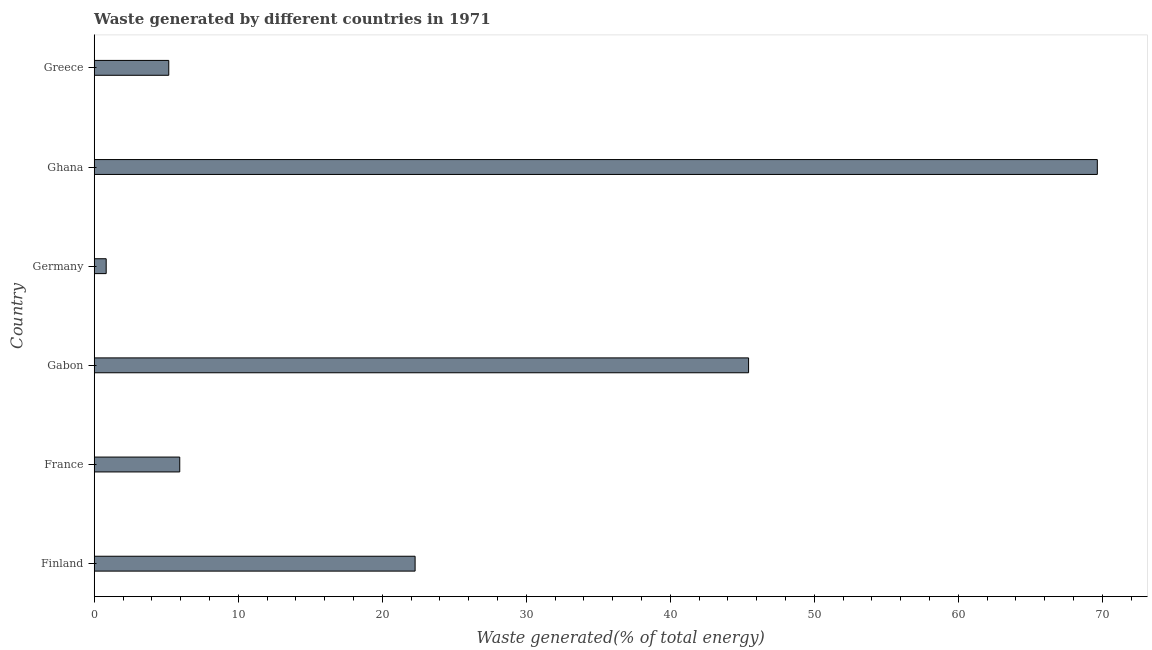Does the graph contain any zero values?
Offer a very short reply. No. Does the graph contain grids?
Ensure brevity in your answer.  No. What is the title of the graph?
Your answer should be very brief. Waste generated by different countries in 1971. What is the label or title of the X-axis?
Keep it short and to the point. Waste generated(% of total energy). What is the label or title of the Y-axis?
Keep it short and to the point. Country. What is the amount of waste generated in France?
Keep it short and to the point. 5.94. Across all countries, what is the maximum amount of waste generated?
Offer a terse response. 69.65. Across all countries, what is the minimum amount of waste generated?
Your response must be concise. 0.83. In which country was the amount of waste generated maximum?
Provide a succinct answer. Ghana. In which country was the amount of waste generated minimum?
Ensure brevity in your answer.  Germany. What is the sum of the amount of waste generated?
Your answer should be very brief. 149.32. What is the difference between the amount of waste generated in Germany and Greece?
Offer a very short reply. -4.34. What is the average amount of waste generated per country?
Make the answer very short. 24.89. What is the median amount of waste generated?
Keep it short and to the point. 14.11. In how many countries, is the amount of waste generated greater than 12 %?
Provide a succinct answer. 3. What is the ratio of the amount of waste generated in Finland to that in Ghana?
Ensure brevity in your answer.  0.32. Is the amount of waste generated in Gabon less than that in Germany?
Offer a very short reply. No. What is the difference between the highest and the second highest amount of waste generated?
Offer a very short reply. 24.22. Is the sum of the amount of waste generated in Gabon and Germany greater than the maximum amount of waste generated across all countries?
Offer a terse response. No. What is the difference between the highest and the lowest amount of waste generated?
Give a very brief answer. 68.82. How many bars are there?
Your answer should be very brief. 6. Are the values on the major ticks of X-axis written in scientific E-notation?
Provide a short and direct response. No. What is the Waste generated(% of total energy) in Finland?
Your answer should be very brief. 22.28. What is the Waste generated(% of total energy) in France?
Provide a succinct answer. 5.94. What is the Waste generated(% of total energy) of Gabon?
Your response must be concise. 45.44. What is the Waste generated(% of total energy) of Germany?
Make the answer very short. 0.83. What is the Waste generated(% of total energy) of Ghana?
Offer a terse response. 69.65. What is the Waste generated(% of total energy) of Greece?
Keep it short and to the point. 5.18. What is the difference between the Waste generated(% of total energy) in Finland and France?
Provide a short and direct response. 16.34. What is the difference between the Waste generated(% of total energy) in Finland and Gabon?
Your answer should be very brief. -23.16. What is the difference between the Waste generated(% of total energy) in Finland and Germany?
Provide a succinct answer. 21.45. What is the difference between the Waste generated(% of total energy) in Finland and Ghana?
Provide a succinct answer. -47.37. What is the difference between the Waste generated(% of total energy) in Finland and Greece?
Your response must be concise. 17.1. What is the difference between the Waste generated(% of total energy) in France and Gabon?
Your answer should be compact. -39.5. What is the difference between the Waste generated(% of total energy) in France and Germany?
Keep it short and to the point. 5.11. What is the difference between the Waste generated(% of total energy) in France and Ghana?
Your answer should be very brief. -63.71. What is the difference between the Waste generated(% of total energy) in France and Greece?
Provide a short and direct response. 0.76. What is the difference between the Waste generated(% of total energy) in Gabon and Germany?
Give a very brief answer. 44.6. What is the difference between the Waste generated(% of total energy) in Gabon and Ghana?
Ensure brevity in your answer.  -24.22. What is the difference between the Waste generated(% of total energy) in Gabon and Greece?
Offer a very short reply. 40.26. What is the difference between the Waste generated(% of total energy) in Germany and Ghana?
Keep it short and to the point. -68.82. What is the difference between the Waste generated(% of total energy) in Germany and Greece?
Give a very brief answer. -4.34. What is the difference between the Waste generated(% of total energy) in Ghana and Greece?
Your answer should be compact. 64.48. What is the ratio of the Waste generated(% of total energy) in Finland to that in France?
Give a very brief answer. 3.75. What is the ratio of the Waste generated(% of total energy) in Finland to that in Gabon?
Give a very brief answer. 0.49. What is the ratio of the Waste generated(% of total energy) in Finland to that in Germany?
Give a very brief answer. 26.77. What is the ratio of the Waste generated(% of total energy) in Finland to that in Ghana?
Give a very brief answer. 0.32. What is the ratio of the Waste generated(% of total energy) in Finland to that in Greece?
Your response must be concise. 4.3. What is the ratio of the Waste generated(% of total energy) in France to that in Gabon?
Give a very brief answer. 0.13. What is the ratio of the Waste generated(% of total energy) in France to that in Germany?
Your answer should be compact. 7.14. What is the ratio of the Waste generated(% of total energy) in France to that in Ghana?
Provide a succinct answer. 0.09. What is the ratio of the Waste generated(% of total energy) in France to that in Greece?
Your answer should be very brief. 1.15. What is the ratio of the Waste generated(% of total energy) in Gabon to that in Germany?
Provide a short and direct response. 54.58. What is the ratio of the Waste generated(% of total energy) in Gabon to that in Ghana?
Provide a succinct answer. 0.65. What is the ratio of the Waste generated(% of total energy) in Gabon to that in Greece?
Provide a short and direct response. 8.78. What is the ratio of the Waste generated(% of total energy) in Germany to that in Ghana?
Ensure brevity in your answer.  0.01. What is the ratio of the Waste generated(% of total energy) in Germany to that in Greece?
Your response must be concise. 0.16. What is the ratio of the Waste generated(% of total energy) in Ghana to that in Greece?
Your response must be concise. 13.45. 